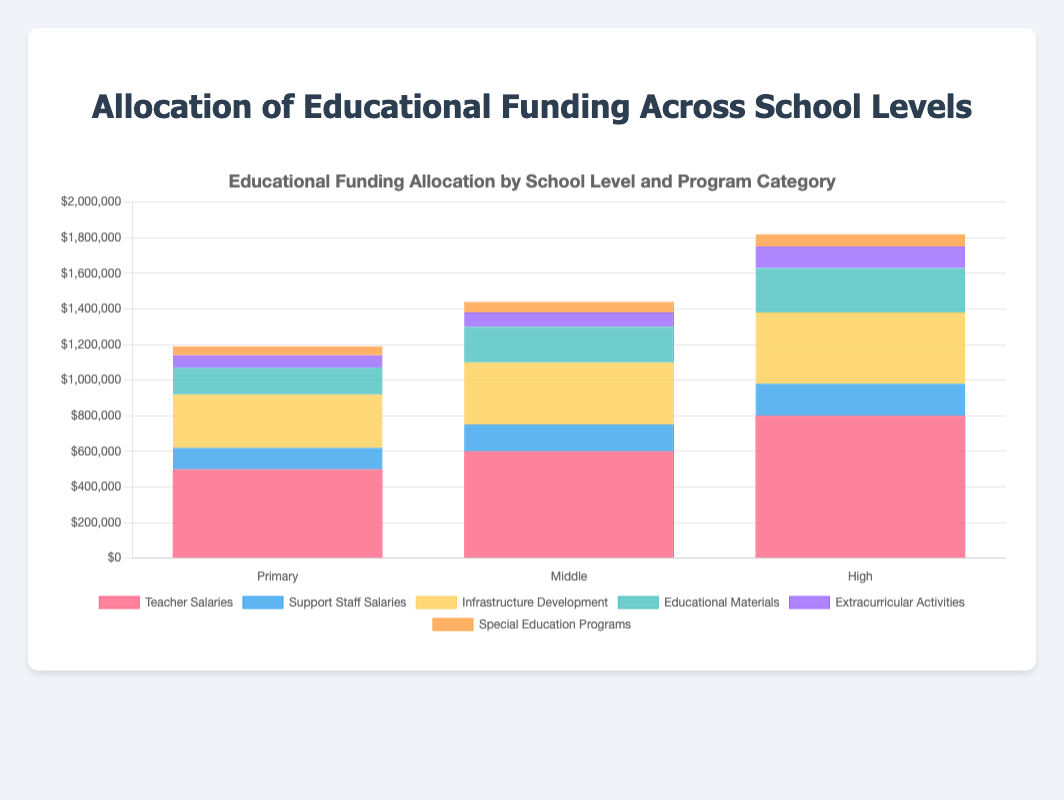Which program category has the highest allocation in primary schools? The highest bar for primary schools represents the largest allocation, which is for Teacher Salaries.
Answer: Teacher Salaries How much more is allocated to Teacher Salaries in high schools compared to primary schools? The Teacher Salaries for high schools is $800,000, and for primary schools, it is $500,000. The difference is $800,000 - $500,000.
Answer: $300,000 Which school level has the least funding allocated to Extracurricular Activities? By comparing the heights of the Extracurricular Activities segments across all school levels, primary schools have the smallest segment.
Answer: Primary What is the total allocation for Infrastructure Development across all school levels? Sum the values for Infrastructure Development in all school levels: $300,000 (Primary) + $350,000 (Middle) + $400,000 (High). The result is $1,050,000.
Answer: $1,050,000 Which program category currently has the same allocation in two different school levels? Observing the stacks, Special Education Programs allocation is $50,000 in primary schools and $50,000 in high schools.
Answer: Special Education Programs Which school level allocates the most to Educational Materials? The highest segment for Educational Materials, visually the greatest height, is found in high schools with $250,000.
Answer: High How much is the total allocation for Support Staff Salaries across all school levels? Sum the values for Support Staff Salaries: $120,000 (Primary) + $150,000 (Middle) + $180,000 (High), yielding $450,000.
Answer: $450,000 What's the difference between the highest and lowest total funding allocations for any school level? Total allocations are $1,190,000 (Primary), $1,440,000 (Middle), and $1,700,000 (High). The difference between High and Primary is $1,700,000 - $1,190,000.
Answer: $510,000 Which program category shows a consistent increase in funding from primary to high school levels? By comparing each category, Teacher Salaries show consistent increase: $500,000 (Primary), $600,000 (Middle), $800,000 (High).
Answer: Teacher Salaries What is the combined funding for Extracurricular Activities and Special Education Programs in middle schools? Sum the values for Extracurricular Activities ($80,000) and Special Education Programs ($60,000) in middle schools. The total is $80,000 + $60,000 = $140,000.
Answer: $140,000 